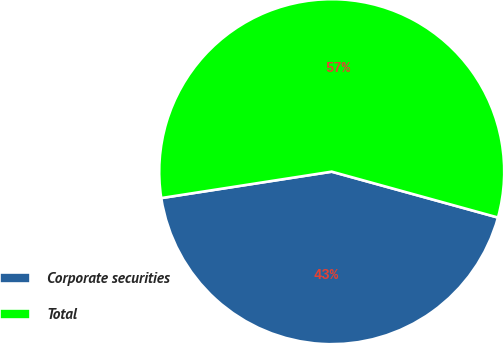<chart> <loc_0><loc_0><loc_500><loc_500><pie_chart><fcel>Corporate securities<fcel>Total<nl><fcel>43.27%<fcel>56.73%<nl></chart> 